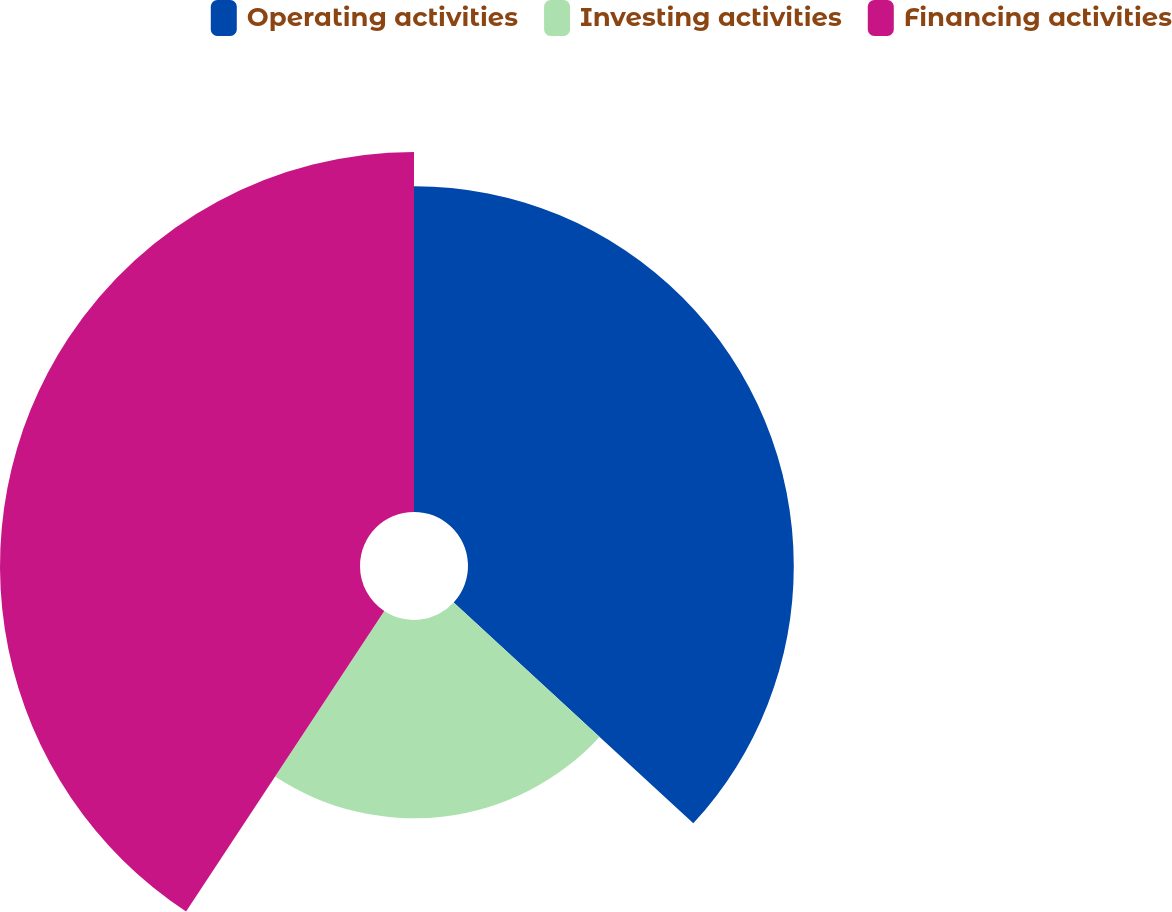<chart> <loc_0><loc_0><loc_500><loc_500><pie_chart><fcel>Operating activities<fcel>Investing activities<fcel>Financing activities<nl><fcel>36.85%<fcel>22.43%<fcel>40.72%<nl></chart> 